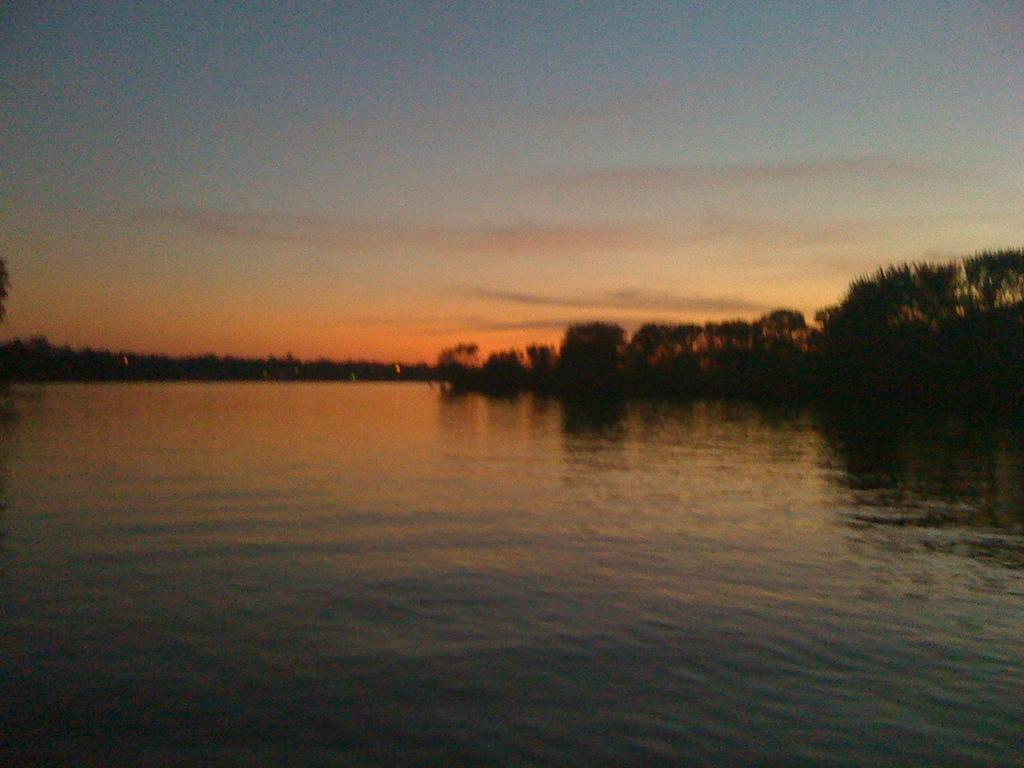What is visible in the image? Water, trees, and the sky are visible in the image. Can you describe the natural setting in the image? The natural setting includes water and trees. What is visible in the background of the image? The sky is visible in the background of the image. What type of rhythm can be heard coming from the group of people in the image? There is no group of people present in the image, so it's not possible to determine what, if any, rhythm might be heard. 